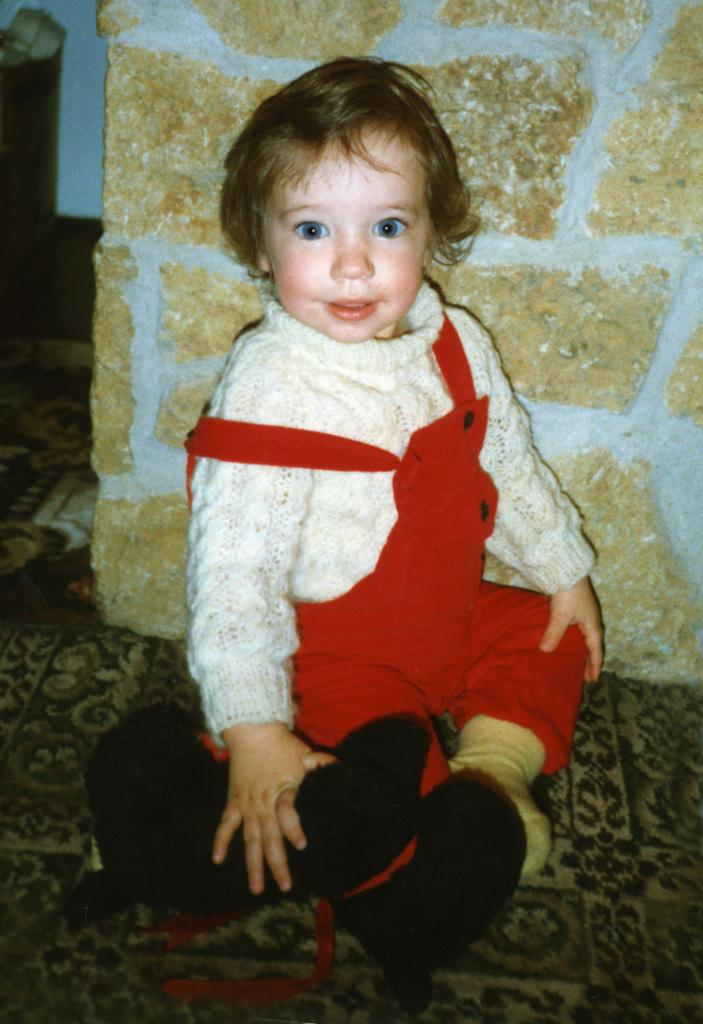What is the main subject of the image? The main subject of the image is a kid. What is the kid doing in the image? The kid is sitting on the floor in the image. What is the kid holding in the image? The kid is holding a toy in the image. What can be seen in the background of the image? There is a wall in the background of the image. How many sisters does the kid have in the image? There is no mention of sisters in the image, so we cannot determine the number of sisters the kid has. 